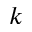<formula> <loc_0><loc_0><loc_500><loc_500>k</formula> 